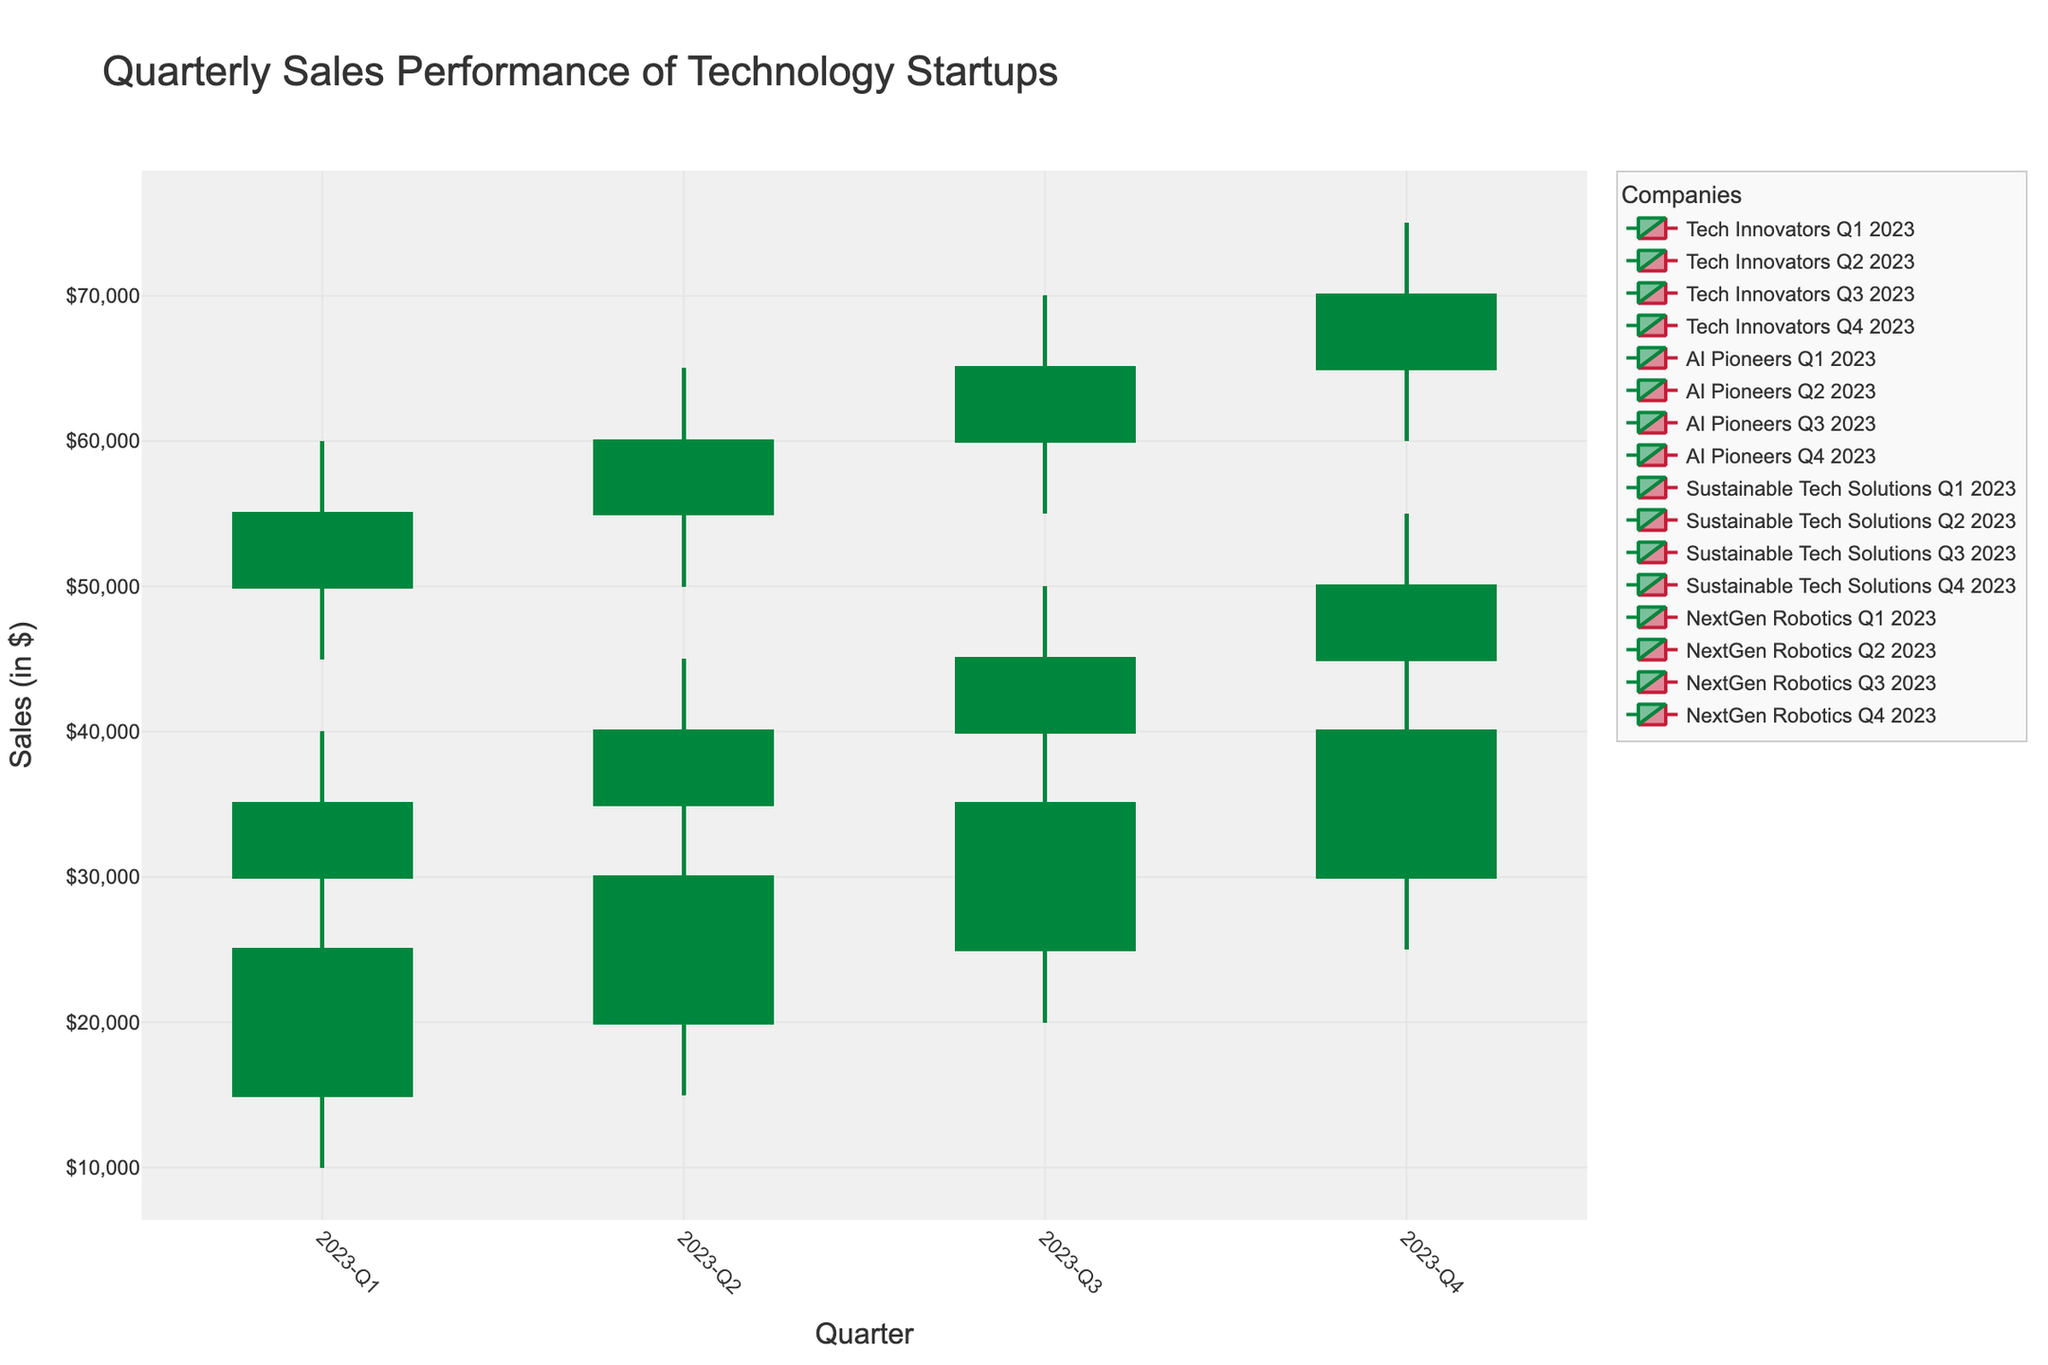what is the title of the figure? The title of the figure is "Quarterly Sales Performance of Technology Startups." This can be seen at the top of the chart.
Answer: Quarterly Sales Performance of Technology Startups How many companies are shown in the figure? The figure shows four companies. This can be inferred by looking at the legend, which lists all the involved companies.
Answer: Four Which quarter had the highest sales for "Tech Innovators"? To find the highest sales for "Tech Innovators," look at the candlestick figures for each quarter and identify the highest value in the 'High' column. The highest value for "Tech Innovators" is in Q4 2023, which reached $75,000.
Answer: Q4 2023 What's the difference between the highest and lowest quarterly sales for "AI Pioneers" in 2023? To find the difference, identify the highest 'High' value and the lowest 'Low' value for "AI Pioneers". The highest value is $55,000 in Q4, and the lowest is $25,000 in Q1. The difference is $55,000 - $25,000 = $30,000.
Answer: $30,000 Which company had the most consistent increase in closing sales throughout 2023? To determine consistency, examine the closing sales values for each quarter across all companies. "Tech Innovators" show a consistent increase in closing values: $55,000, $60,000, $65,000, $70,000.
Answer: Tech Innovators Compare the Q2 2023 sales performance between "Sustainable Tech Solutions" and "NextGen Robotics." Which had higher sales? Check both the highest values for Q2 2023. "Sustainable Tech Solutions" has a high of $35,000, while "NextGen Robotics" has a high of $30,000. Therefore, "Sustainable Tech Solutions" had higher sales in Q2 2023.
Answer: Sustainable Tech Solutions What was the average closing sales for "NextGen Robotics" in 2023? Sum the closing sales for each quarter: $20,000 + $25,000 + $30,000 + $35,000. Then, divide by the number of quarters (4): ($20,000 + $25,000 + $30,000 + $35,000) / 4 = $27,500.
Answer: $27,500 In which quarter did "Sustainable Tech Solutions" show the greatest increase in sales from its opening to its closing value? Compute the difference between opening and closing sales for each quarter and compare: Q1: $5,000, Q2: $5,000, Q3: $5,000, Q4: $5,000. The greatest increase is the same for all quarters, at $5,000.
Answer: All quarters How do the highest sales of "AI Pioneers" in Q4 compare to the highest sales of "Tech Innovators" in Q3? The highest sales for "AI Pioneers" in Q4 is $55,000, while for "Tech Innovators" in Q3 it is $70,000. Therefore, "Tech Innovators" has higher sales.
Answer: Tech Innovators What is the range of sales values for "Sustainable Tech Solutions" in Q1? Identify the highest and lowest values for "Sustainable Tech Solutions" in Q1 and find the difference. High is $30,000 and low is $15,000; range is $30,000 - $15,000 = $15,000.
Answer: $15,000 